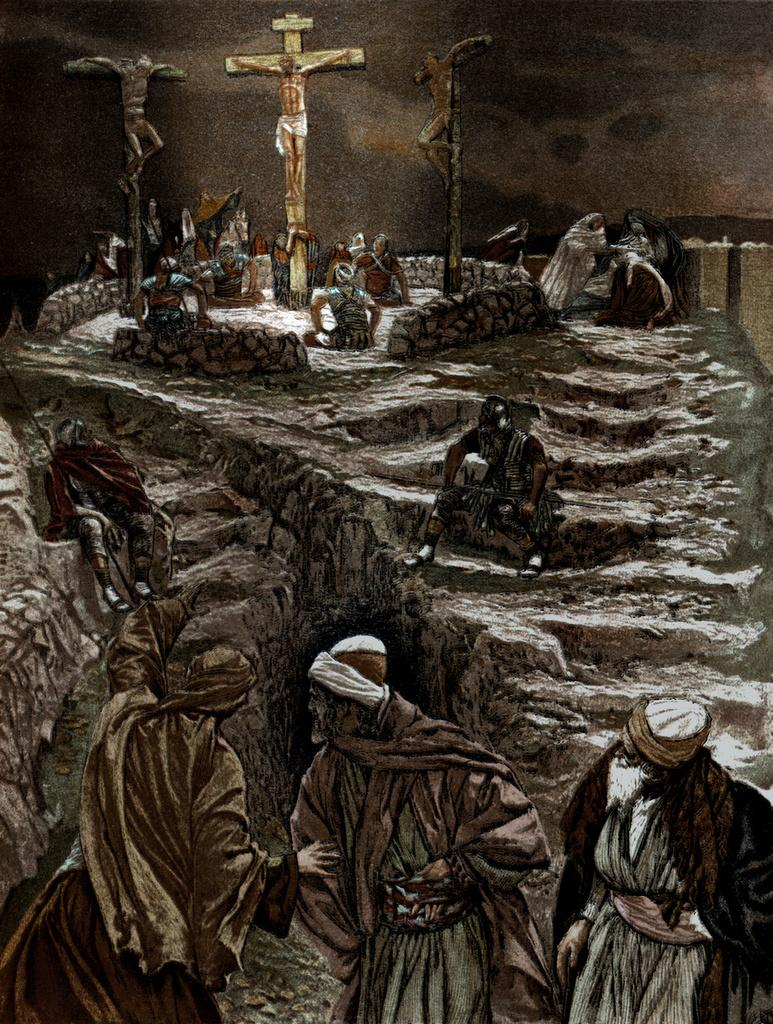How many people are present in the image? There are three persons standing in the image. What can be seen in the background of the image? There are stairs visible in the background of the image, and people are sitting on the stairs. Is there any religious symbolism in the image? Yes, there is a symbol of a god in the background of the image. What type of mask is being worn by the person on the left in the image? There is no mask visible on any person in the image. 